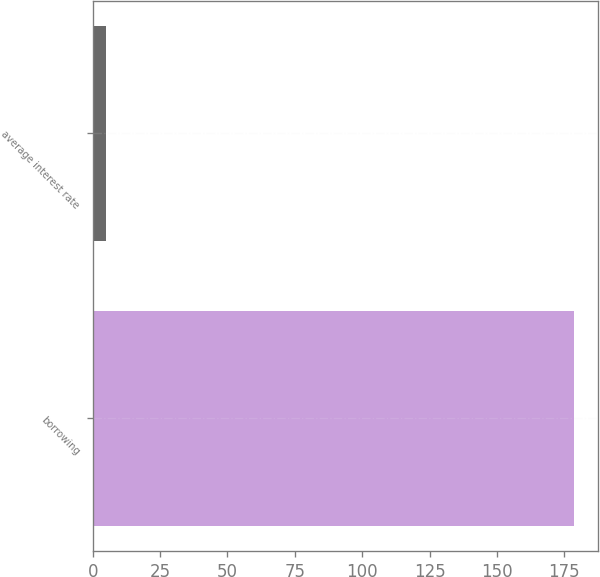<chart> <loc_0><loc_0><loc_500><loc_500><bar_chart><fcel>borrowing<fcel>average interest rate<nl><fcel>178.4<fcel>5<nl></chart> 